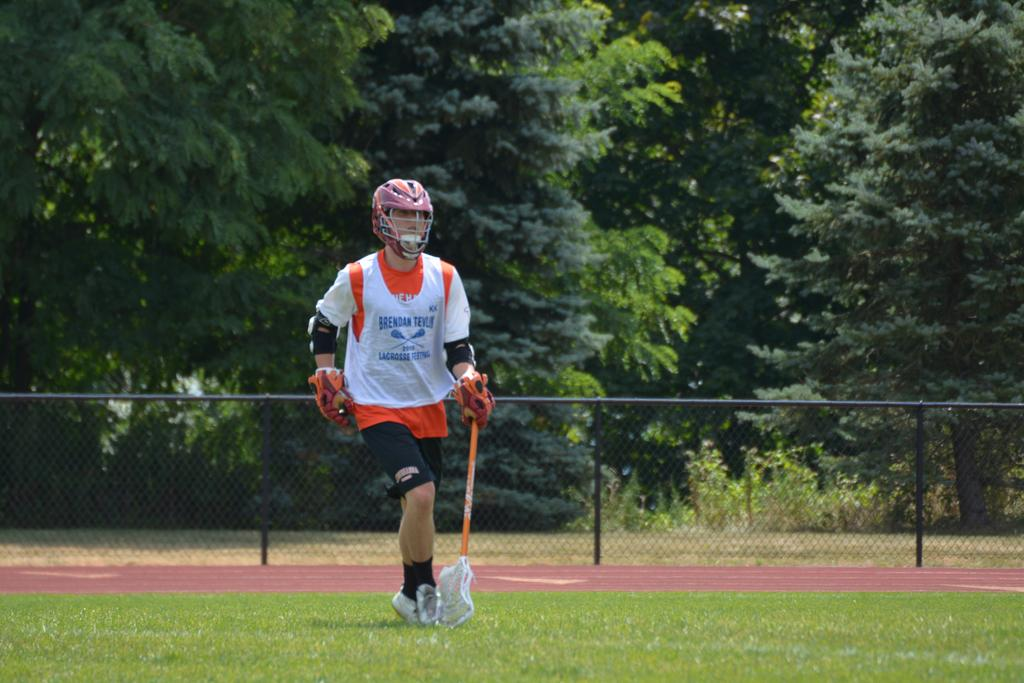<image>
Offer a succinct explanation of the picture presented. A player has a shirt on that has the word lacrosse on it. 